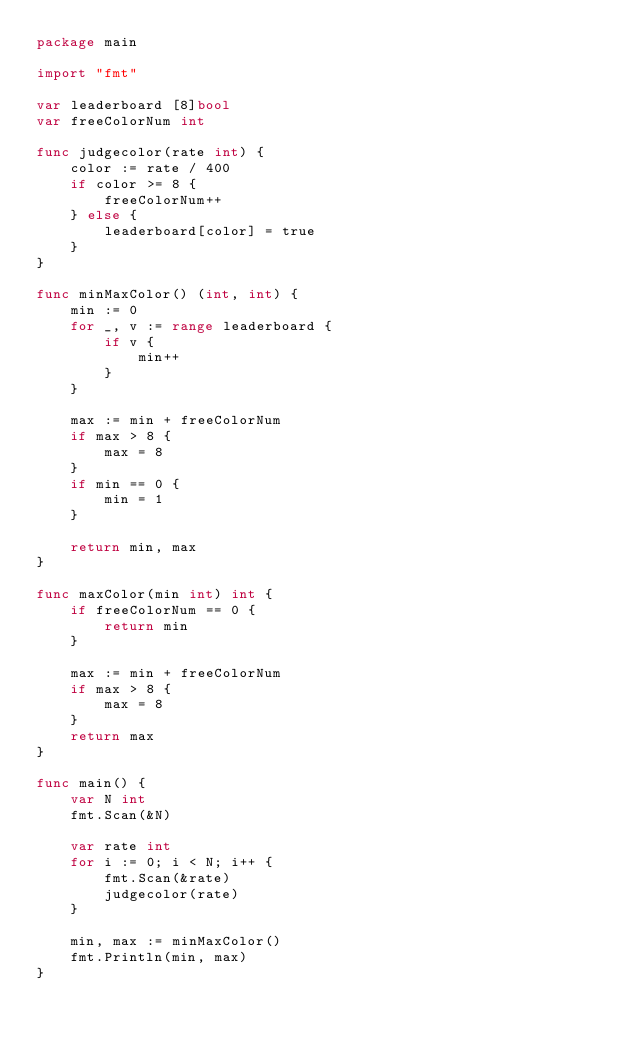<code> <loc_0><loc_0><loc_500><loc_500><_Go_>package main

import "fmt"

var leaderboard [8]bool
var freeColorNum int

func judgecolor(rate int) {
	color := rate / 400
	if color >= 8 {
		freeColorNum++
	} else {
		leaderboard[color] = true
	}
}

func minMaxColor() (int, int) {
	min := 0
	for _, v := range leaderboard {
		if v {
			min++
		}
	}

	max := min + freeColorNum
	if max > 8 {
		max = 8
	}
	if min == 0 {
		min = 1
	}

	return min, max
}

func maxColor(min int) int {
	if freeColorNum == 0 {
		return min
	}

	max := min + freeColorNum
	if max > 8 {
		max = 8
	}
	return max
}

func main() {
	var N int
	fmt.Scan(&N)

	var rate int
	for i := 0; i < N; i++ {
		fmt.Scan(&rate)
		judgecolor(rate)
	}

	min, max := minMaxColor()
	fmt.Println(min, max)
}
</code> 